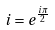<formula> <loc_0><loc_0><loc_500><loc_500>i = e ^ { \frac { i \pi } { 2 } }</formula> 